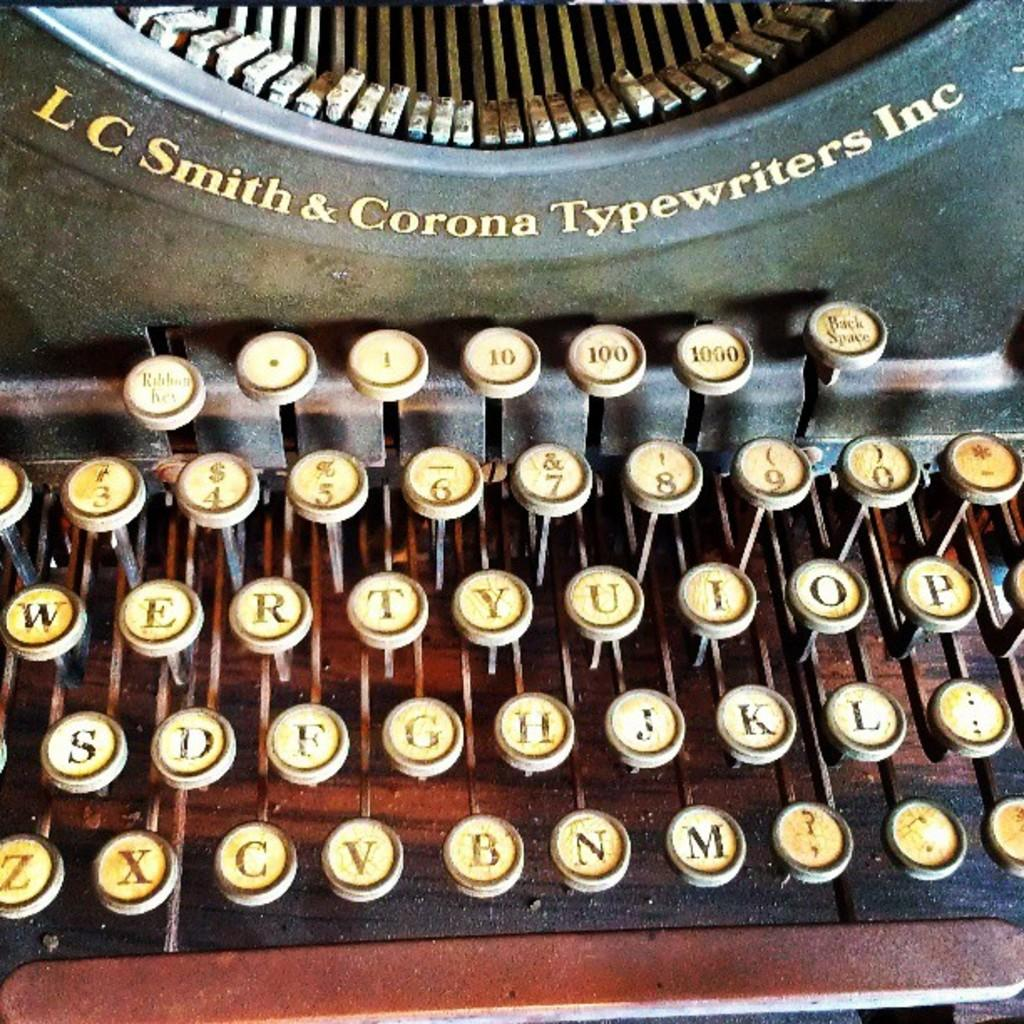<image>
Create a compact narrative representing the image presented. The vintage typewriter has the name LC Smith & Corona Typewriters Inc on it. 